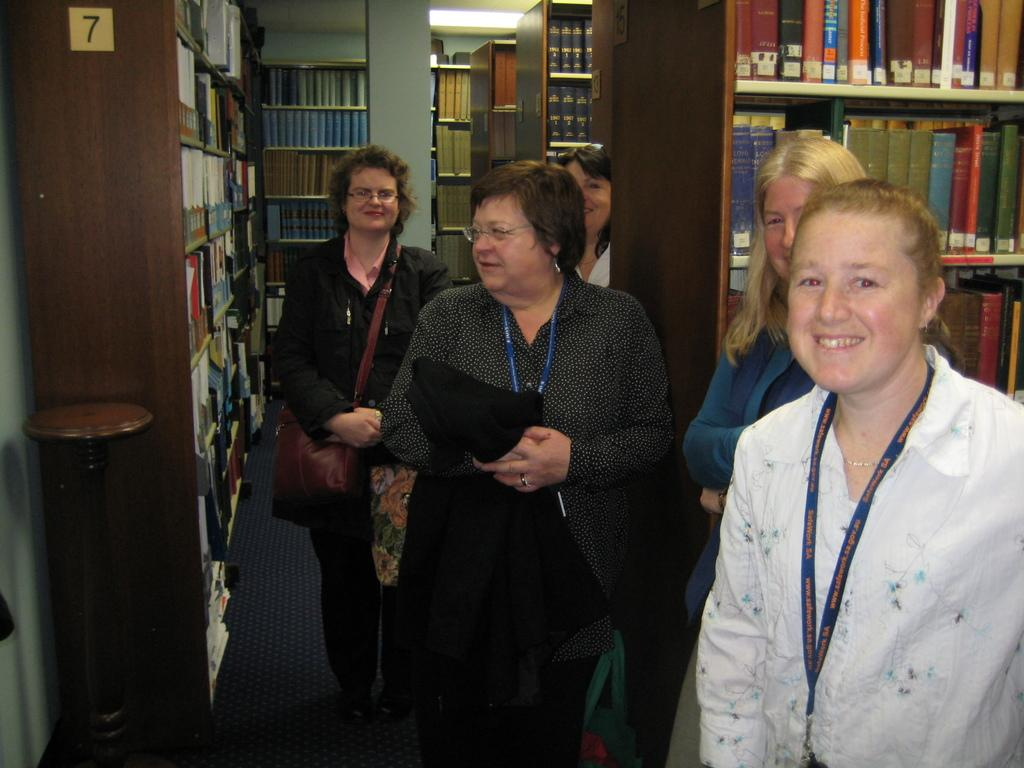How many ladies are in the image? There are five ladies in the center of the image. What can be seen in the background of the image? There are bookshelves in the background of the image. Can you describe the bookshelf on the right side of the image? Yes, there is a bookshelf to the right side of the image. What type of sticks are being used to create harmony in the image? There are no sticks or any indication of harmony present in the image. 